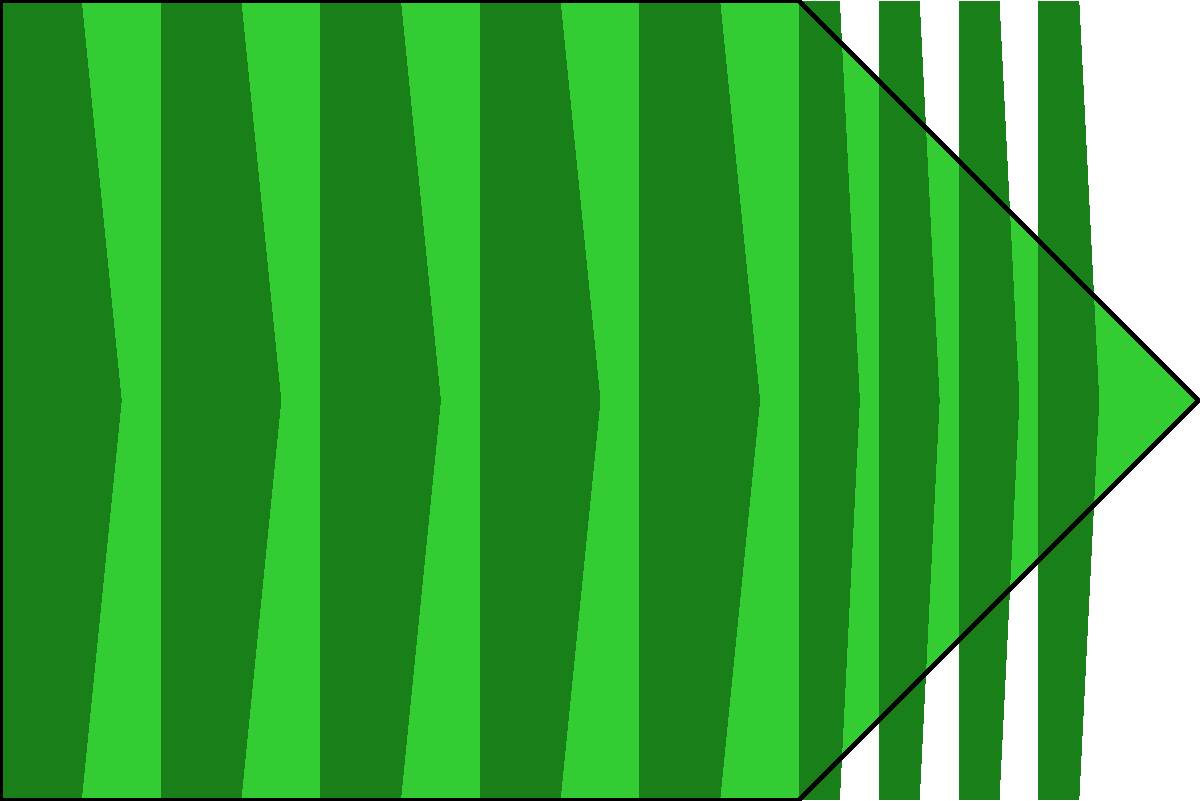What type of grass pattern is displayed on this baseball field, and what is its primary purpose? To identify the grass pattern and its purpose, let's analyze the image step-by-step:

1. The image shows a simplified top-down view of a baseball field's grass area.
2. The grass is not uniform in color; there are alternating light and dark green stripes.
3. The stripes are not straight but have a slight curve or arc to them.
4. The pattern is consistent across the entire field, with narrower stripes in the infield and wider stripes in the outfield.

This pattern is known as "striping" or "lawn striping." It's created by mowing the grass in alternating directions, causing the grass blades to bend in opposite directions. This bending reflects light differently, creating the visual effect of light and dark stripes.

The primary purposes of this striping pattern are:

1. Aesthetics: It creates a visually appealing, professional look for the field.
2. Player orientation: The stripes can help fielders judge distances and positions on the field.
3. Ball roll: The alternating directions of the grass can slightly affect how the ball rolls, adding an element of strategy to the game.
4. Turf health: Mowing in different directions prevents wear patterns and promotes even growth.

Therefore, this grass pattern is a deliberate maintenance technique used by groundskeepers to enhance both the appearance and functionality of the baseball field.
Answer: Striping; aesthetics and player orientation 